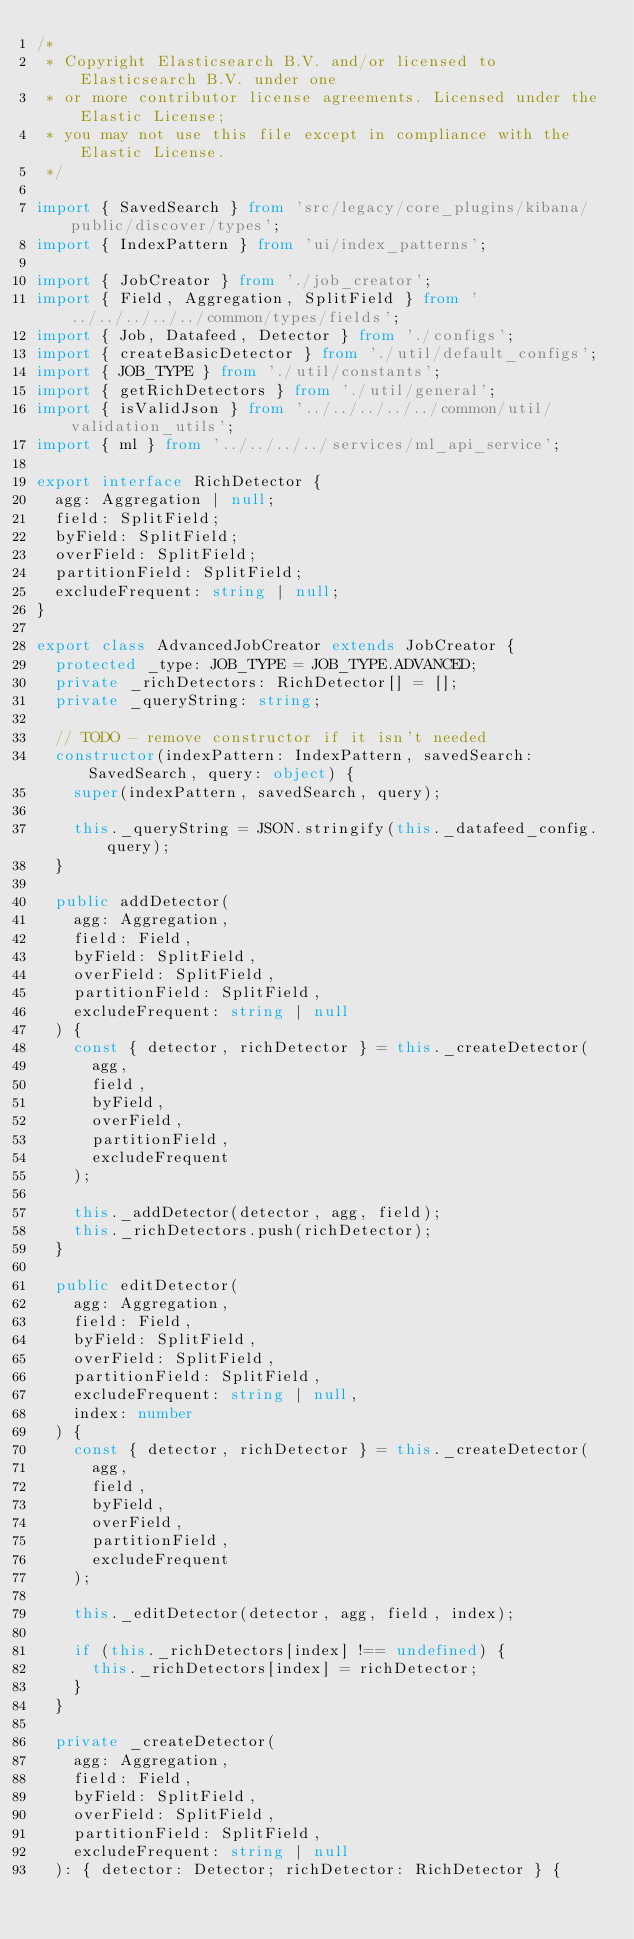Convert code to text. <code><loc_0><loc_0><loc_500><loc_500><_TypeScript_>/*
 * Copyright Elasticsearch B.V. and/or licensed to Elasticsearch B.V. under one
 * or more contributor license agreements. Licensed under the Elastic License;
 * you may not use this file except in compliance with the Elastic License.
 */

import { SavedSearch } from 'src/legacy/core_plugins/kibana/public/discover/types';
import { IndexPattern } from 'ui/index_patterns';

import { JobCreator } from './job_creator';
import { Field, Aggregation, SplitField } from '../../../../../common/types/fields';
import { Job, Datafeed, Detector } from './configs';
import { createBasicDetector } from './util/default_configs';
import { JOB_TYPE } from './util/constants';
import { getRichDetectors } from './util/general';
import { isValidJson } from '../../../../../common/util/validation_utils';
import { ml } from '../../../../services/ml_api_service';

export interface RichDetector {
  agg: Aggregation | null;
  field: SplitField;
  byField: SplitField;
  overField: SplitField;
  partitionField: SplitField;
  excludeFrequent: string | null;
}

export class AdvancedJobCreator extends JobCreator {
  protected _type: JOB_TYPE = JOB_TYPE.ADVANCED;
  private _richDetectors: RichDetector[] = [];
  private _queryString: string;

  // TODO - remove constructor if it isn't needed
  constructor(indexPattern: IndexPattern, savedSearch: SavedSearch, query: object) {
    super(indexPattern, savedSearch, query);

    this._queryString = JSON.stringify(this._datafeed_config.query);
  }

  public addDetector(
    agg: Aggregation,
    field: Field,
    byField: SplitField,
    overField: SplitField,
    partitionField: SplitField,
    excludeFrequent: string | null
  ) {
    const { detector, richDetector } = this._createDetector(
      agg,
      field,
      byField,
      overField,
      partitionField,
      excludeFrequent
    );

    this._addDetector(detector, agg, field);
    this._richDetectors.push(richDetector);
  }

  public editDetector(
    agg: Aggregation,
    field: Field,
    byField: SplitField,
    overField: SplitField,
    partitionField: SplitField,
    excludeFrequent: string | null,
    index: number
  ) {
    const { detector, richDetector } = this._createDetector(
      agg,
      field,
      byField,
      overField,
      partitionField,
      excludeFrequent
    );

    this._editDetector(detector, agg, field, index);

    if (this._richDetectors[index] !== undefined) {
      this._richDetectors[index] = richDetector;
    }
  }

  private _createDetector(
    agg: Aggregation,
    field: Field,
    byField: SplitField,
    overField: SplitField,
    partitionField: SplitField,
    excludeFrequent: string | null
  ): { detector: Detector; richDetector: RichDetector } {</code> 